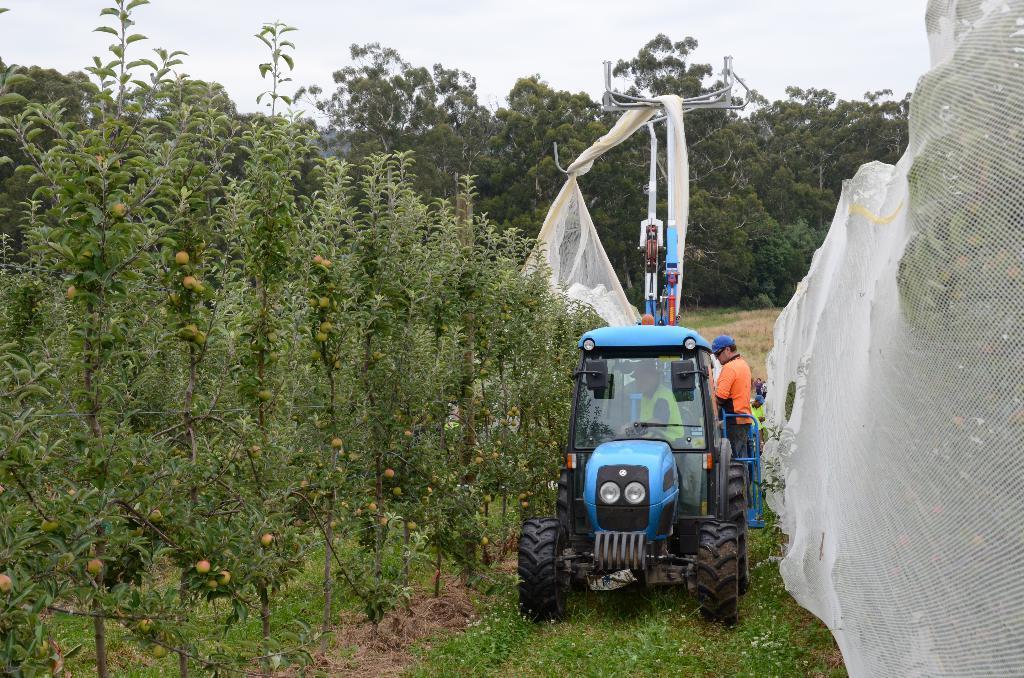Describe this image in one or two sentences. On the left side, there are plants having fruits and grass on the ground. In the middle, there is a vehicle on the grass on the ground. On the right side, there is white color net. In the background, there are trees and grass on the ground and there are clouds in the sky. 